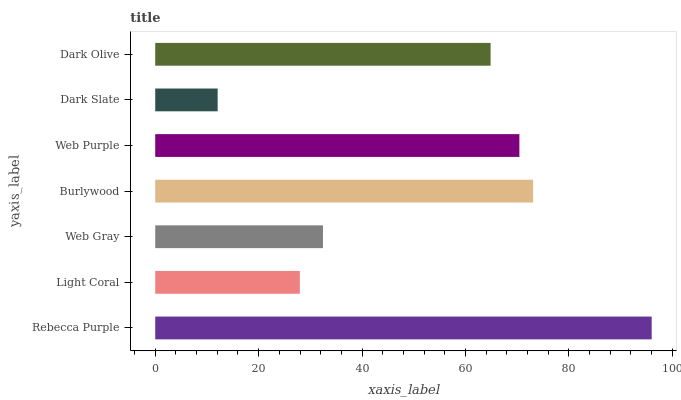Is Dark Slate the minimum?
Answer yes or no. Yes. Is Rebecca Purple the maximum?
Answer yes or no. Yes. Is Light Coral the minimum?
Answer yes or no. No. Is Light Coral the maximum?
Answer yes or no. No. Is Rebecca Purple greater than Light Coral?
Answer yes or no. Yes. Is Light Coral less than Rebecca Purple?
Answer yes or no. Yes. Is Light Coral greater than Rebecca Purple?
Answer yes or no. No. Is Rebecca Purple less than Light Coral?
Answer yes or no. No. Is Dark Olive the high median?
Answer yes or no. Yes. Is Dark Olive the low median?
Answer yes or no. Yes. Is Light Coral the high median?
Answer yes or no. No. Is Web Gray the low median?
Answer yes or no. No. 